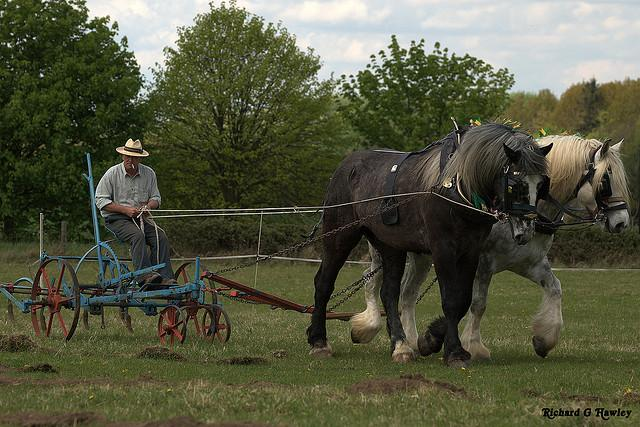What is he doing? Please explain your reasoning. plowing field. Horses serve many purposes however when they are in a field with a harness and plow on them, they are probably doing this. 